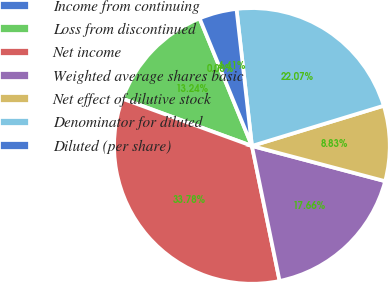Convert chart. <chart><loc_0><loc_0><loc_500><loc_500><pie_chart><fcel>Income from continuing<fcel>Loss from discontinued<fcel>Net income<fcel>Weighted average shares basic<fcel>Net effect of dilutive stock<fcel>Denominator for diluted<fcel>Diluted (per share)<nl><fcel>0.0%<fcel>13.24%<fcel>33.78%<fcel>17.66%<fcel>8.83%<fcel>22.07%<fcel>4.41%<nl></chart> 